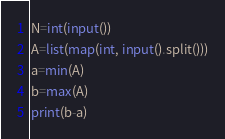<code> <loc_0><loc_0><loc_500><loc_500><_Python_>N=int(input())
A=list(map(int, input().split()))
a=min(A)
b=max(A)
print(b-a)</code> 